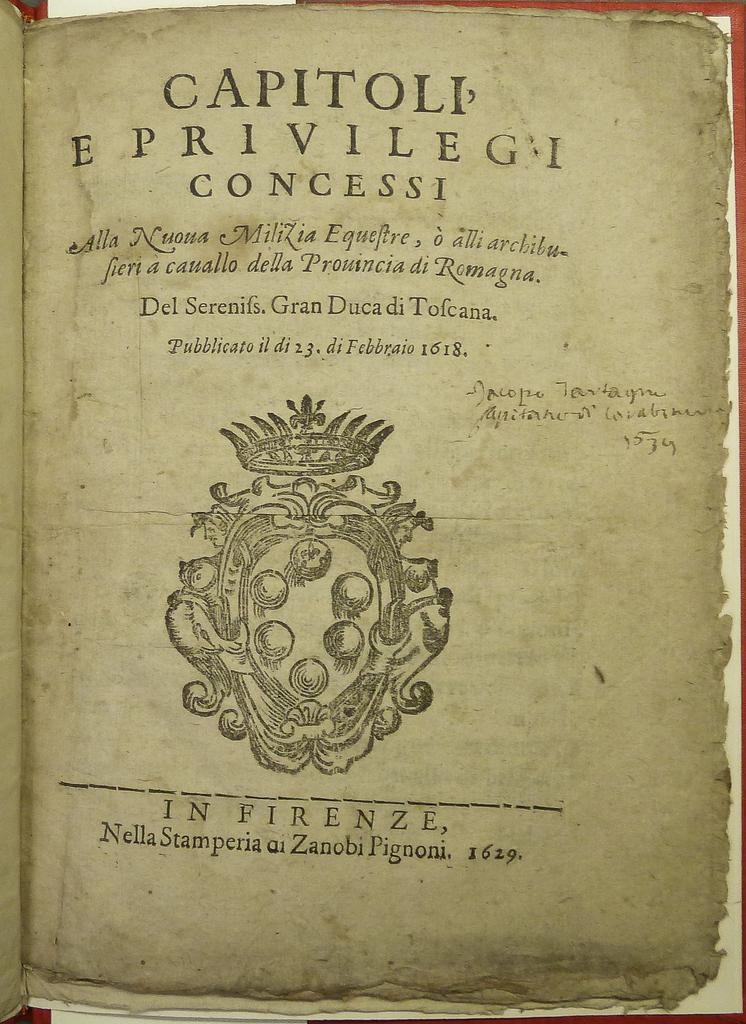<image>
Share a concise interpretation of the image provided. a page that is titled 'capitoli eprivilegei concessi' 